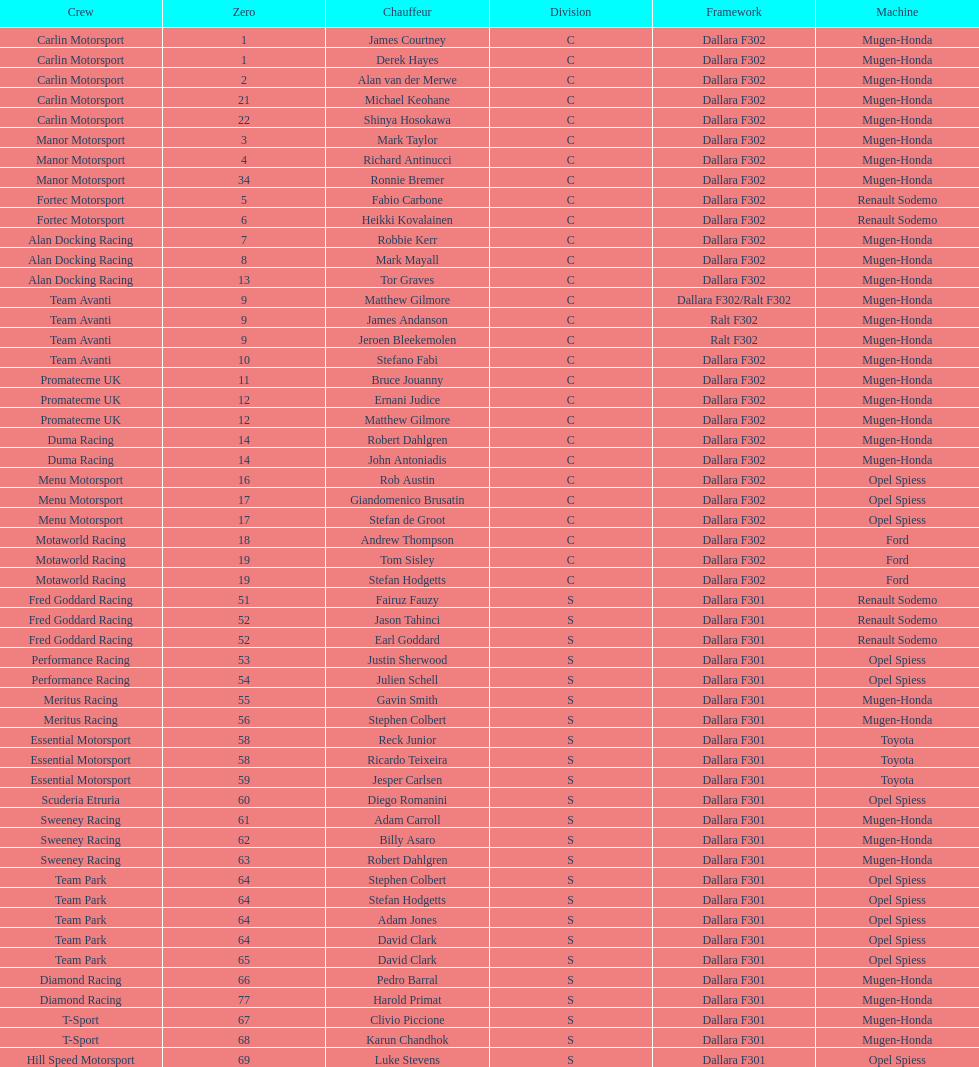Would you mind parsing the complete table? {'header': ['Crew', 'Zero', 'Chauffeur', 'Division', 'Framework', 'Machine'], 'rows': [['Carlin Motorsport', '1', 'James Courtney', 'C', 'Dallara F302', 'Mugen-Honda'], ['Carlin Motorsport', '1', 'Derek Hayes', 'C', 'Dallara F302', 'Mugen-Honda'], ['Carlin Motorsport', '2', 'Alan van der Merwe', 'C', 'Dallara F302', 'Mugen-Honda'], ['Carlin Motorsport', '21', 'Michael Keohane', 'C', 'Dallara F302', 'Mugen-Honda'], ['Carlin Motorsport', '22', 'Shinya Hosokawa', 'C', 'Dallara F302', 'Mugen-Honda'], ['Manor Motorsport', '3', 'Mark Taylor', 'C', 'Dallara F302', 'Mugen-Honda'], ['Manor Motorsport', '4', 'Richard Antinucci', 'C', 'Dallara F302', 'Mugen-Honda'], ['Manor Motorsport', '34', 'Ronnie Bremer', 'C', 'Dallara F302', 'Mugen-Honda'], ['Fortec Motorsport', '5', 'Fabio Carbone', 'C', 'Dallara F302', 'Renault Sodemo'], ['Fortec Motorsport', '6', 'Heikki Kovalainen', 'C', 'Dallara F302', 'Renault Sodemo'], ['Alan Docking Racing', '7', 'Robbie Kerr', 'C', 'Dallara F302', 'Mugen-Honda'], ['Alan Docking Racing', '8', 'Mark Mayall', 'C', 'Dallara F302', 'Mugen-Honda'], ['Alan Docking Racing', '13', 'Tor Graves', 'C', 'Dallara F302', 'Mugen-Honda'], ['Team Avanti', '9', 'Matthew Gilmore', 'C', 'Dallara F302/Ralt F302', 'Mugen-Honda'], ['Team Avanti', '9', 'James Andanson', 'C', 'Ralt F302', 'Mugen-Honda'], ['Team Avanti', '9', 'Jeroen Bleekemolen', 'C', 'Ralt F302', 'Mugen-Honda'], ['Team Avanti', '10', 'Stefano Fabi', 'C', 'Dallara F302', 'Mugen-Honda'], ['Promatecme UK', '11', 'Bruce Jouanny', 'C', 'Dallara F302', 'Mugen-Honda'], ['Promatecme UK', '12', 'Ernani Judice', 'C', 'Dallara F302', 'Mugen-Honda'], ['Promatecme UK', '12', 'Matthew Gilmore', 'C', 'Dallara F302', 'Mugen-Honda'], ['Duma Racing', '14', 'Robert Dahlgren', 'C', 'Dallara F302', 'Mugen-Honda'], ['Duma Racing', '14', 'John Antoniadis', 'C', 'Dallara F302', 'Mugen-Honda'], ['Menu Motorsport', '16', 'Rob Austin', 'C', 'Dallara F302', 'Opel Spiess'], ['Menu Motorsport', '17', 'Giandomenico Brusatin', 'C', 'Dallara F302', 'Opel Spiess'], ['Menu Motorsport', '17', 'Stefan de Groot', 'C', 'Dallara F302', 'Opel Spiess'], ['Motaworld Racing', '18', 'Andrew Thompson', 'C', 'Dallara F302', 'Ford'], ['Motaworld Racing', '19', 'Tom Sisley', 'C', 'Dallara F302', 'Ford'], ['Motaworld Racing', '19', 'Stefan Hodgetts', 'C', 'Dallara F302', 'Ford'], ['Fred Goddard Racing', '51', 'Fairuz Fauzy', 'S', 'Dallara F301', 'Renault Sodemo'], ['Fred Goddard Racing', '52', 'Jason Tahinci', 'S', 'Dallara F301', 'Renault Sodemo'], ['Fred Goddard Racing', '52', 'Earl Goddard', 'S', 'Dallara F301', 'Renault Sodemo'], ['Performance Racing', '53', 'Justin Sherwood', 'S', 'Dallara F301', 'Opel Spiess'], ['Performance Racing', '54', 'Julien Schell', 'S', 'Dallara F301', 'Opel Spiess'], ['Meritus Racing', '55', 'Gavin Smith', 'S', 'Dallara F301', 'Mugen-Honda'], ['Meritus Racing', '56', 'Stephen Colbert', 'S', 'Dallara F301', 'Mugen-Honda'], ['Essential Motorsport', '58', 'Reck Junior', 'S', 'Dallara F301', 'Toyota'], ['Essential Motorsport', '58', 'Ricardo Teixeira', 'S', 'Dallara F301', 'Toyota'], ['Essential Motorsport', '59', 'Jesper Carlsen', 'S', 'Dallara F301', 'Toyota'], ['Scuderia Etruria', '60', 'Diego Romanini', 'S', 'Dallara F301', 'Opel Spiess'], ['Sweeney Racing', '61', 'Adam Carroll', 'S', 'Dallara F301', 'Mugen-Honda'], ['Sweeney Racing', '62', 'Billy Asaro', 'S', 'Dallara F301', 'Mugen-Honda'], ['Sweeney Racing', '63', 'Robert Dahlgren', 'S', 'Dallara F301', 'Mugen-Honda'], ['Team Park', '64', 'Stephen Colbert', 'S', 'Dallara F301', 'Opel Spiess'], ['Team Park', '64', 'Stefan Hodgetts', 'S', 'Dallara F301', 'Opel Spiess'], ['Team Park', '64', 'Adam Jones', 'S', 'Dallara F301', 'Opel Spiess'], ['Team Park', '64', 'David Clark', 'S', 'Dallara F301', 'Opel Spiess'], ['Team Park', '65', 'David Clark', 'S', 'Dallara F301', 'Opel Spiess'], ['Diamond Racing', '66', 'Pedro Barral', 'S', 'Dallara F301', 'Mugen-Honda'], ['Diamond Racing', '77', 'Harold Primat', 'S', 'Dallara F301', 'Mugen-Honda'], ['T-Sport', '67', 'Clivio Piccione', 'S', 'Dallara F301', 'Mugen-Honda'], ['T-Sport', '68', 'Karun Chandhok', 'S', 'Dallara F301', 'Mugen-Honda'], ['Hill Speed Motorsport', '69', 'Luke Stevens', 'S', 'Dallara F301', 'Opel Spiess']]} Besides clivio piccione, who is the other driver on the t-sport team? Karun Chandhok. 